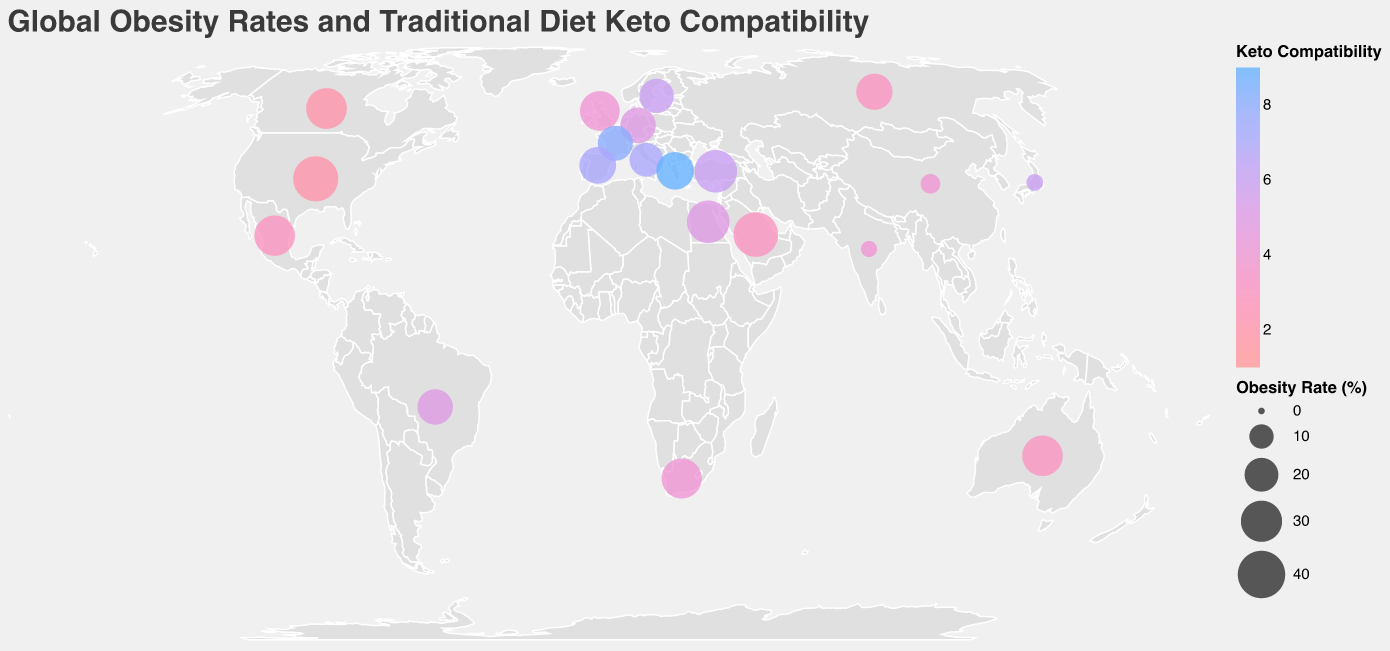What is the title of the figure? The title is written at the top of the figure, describing the plot's focus on global obesity rates and traditional diet keto compatibility.
Answer: Global Obesity Rates and Traditional Diet Keto Compatibility Which country has the highest obesity rate? The United States has the largest circle, indicating the highest obesity rate amongst the listed countries, shown through a larger circle size.
Answer: United States Which countries have an obesity rate below 5%? Looking for the smallest circles (4.3 for Japan and 3.9 for India), these two countries have the lowest indicated obesity rates on the plot.
Answer: Japan and India Which country has the highest keto compatibility score? Greece, with the color towards the blue end of the spectrum, scores a 9, the highest rating for keto compatibility.
Answer: Greece How do obesity rates compare between the United States and Japan? The circle for the United States is significantly larger at 36.2% compared to the much smaller circle for Japan with an obesity rate of 4.3%.
Answer: The obesity rate in the United States is much higher than in Japan What is the average obesity rate of the five countries with the highest keto compatibility scores? Take the countries with keto compatibility scores of 7, 8, or 9 (Italy, France, Spain, Greece, Sweden), then calculate the average of their obesity rates: (19.9 + 21.6 + 23.8 + 24.9 + 20.6) / 5.
Answer: The average is 22.16% Which countries have keto compatibility scores of less than 3 and what are their obesity rates? Identify the countries with keto scores 2 or 3 (United States, Mexico, Russia, Australia, Saudi Arabia, and Canada) and read their obesity rates directly from the plot (36.2, 28.9, 23.1, 29, 35.4, 29.4).
Answer: United States: 36.2%, Mexico: 28.9%, Russia: 23.1%, Australia: 29%, Saudi Arabia: 35.4%, Canada: 29.4% What correlation can you infer between obesity rates and traditional diet keto compatibility? Higher keto compatibility scores do not consistently correlate with lower obesity rates, given a wide variation in obesity despite keto scores (e.g., Greece vs. the United States).
Answer: No consistent correlation Which countries fall within an obesity range of 20% to 25%? Countries with circle sizes in this range include Germany (22.3%), France (21.6%), Spain (23.8%), Greece (24.9%), Russia (23.1%), Brazil (22.1%).
Answer: Germany, France, Spain, Greece, Russia, Brazil 